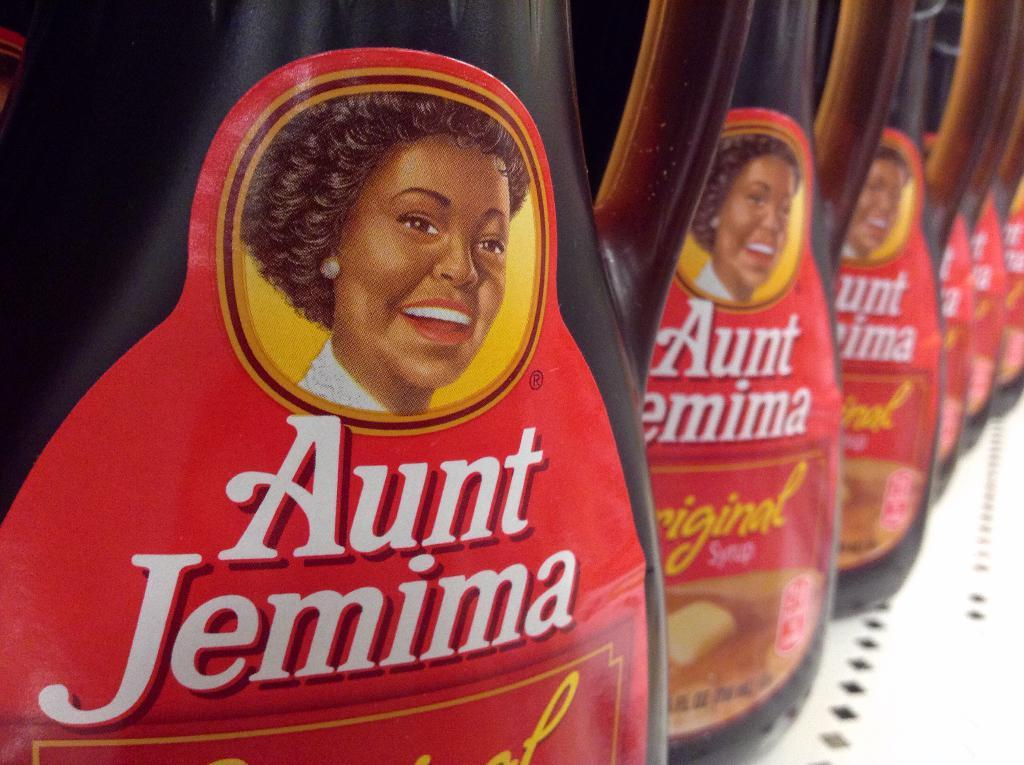What objects can be seen in the image? There are bottles in the image. Where are the bottles located? The bottles are placed on a surface. What type of feast is being prepared on the ground in the image? There is no feast or ground present in the image; it only features bottles placed on a surface. How many lizards can be seen crawling on the bottles in the image? There are no lizards present in the image; it only features bottles placed on a surface. 